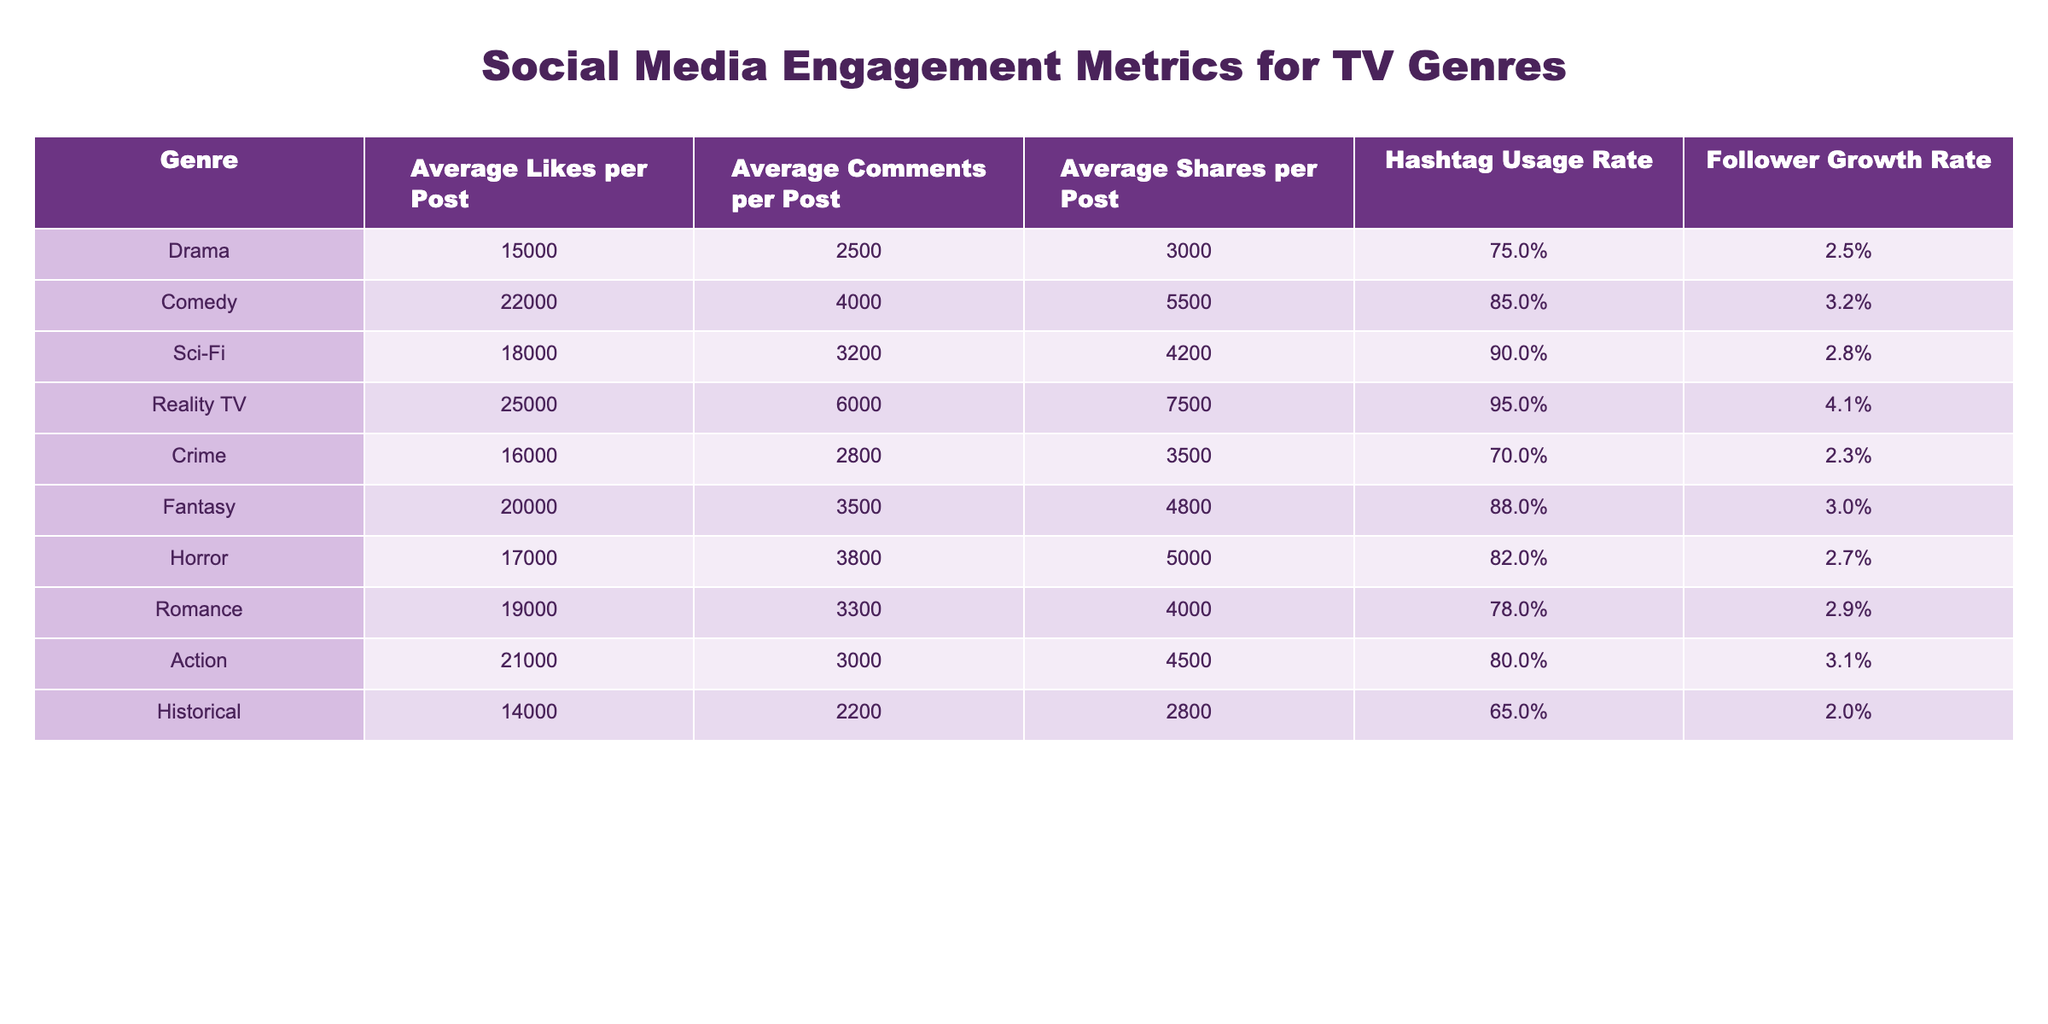What genre has the highest average likes per post? By checking the "Average Likes per Post" column, the highest value is 25000, which corresponds to the genre "Reality TV."
Answer: Reality TV Which genre has the lowest follower growth rate? Looking at the "Follower Growth Rate" column, the lowest percentage is 2.0%, which is associated with the genre "Historical."
Answer: Historical What is the average number of shares per post for comedies? The "Average Shares per Post" for the genre "Comedy" is listed as 5500.
Answer: 5500 What is the combined average likes for Drama and Crime genres? To find the combined average likes, we sum the average likes for Drama (15000) and Crime (16000), giving us a total of 31000. Then, we divide by 2 to find the average: 31000/2 = 15500.
Answer: 15500 Does the Sci-Fi genre have more average comments per post than the Horror genre? The average comments per post for Sci-Fi is 3200, while for Horror, it is 3800. Since 3200 is less than 3800, the statement is false.
Answer: No What is the total average likes across all genres listed in the table? First, we add up all the average likes: 15000 + 22000 + 18000 + 25000 + 16000 + 20000 + 17000 + 19000 + 21000 + 14000 = 183000. Then, to get the total, we don't need to divide since it's the combined figure.
Answer: 183000 Which genre uses hashtags the least? By examining the "Hashtag Usage Rate" column, the lowest value is 65%, corresponding to the genre "Historical."
Answer: Historical What is the difference in average comments per post between Action and Reality TV? The average comments for Action is 3000 and for Reality TV it's 6000. The difference is 6000 - 3000 = 3000.
Answer: 3000 Which genre shows the highest follower growth rate and what is the percentage? The "Follower Growth Rate" for Reality TV is the highest at 4.1%.
Answer: 4.1% Is the average shares per post for Fantasy greater than that for Drama? The average shares for Fantasy is 4800 and for Drama it is 3000. Since 4800 is greater than 3000, the statement is true.
Answer: Yes 